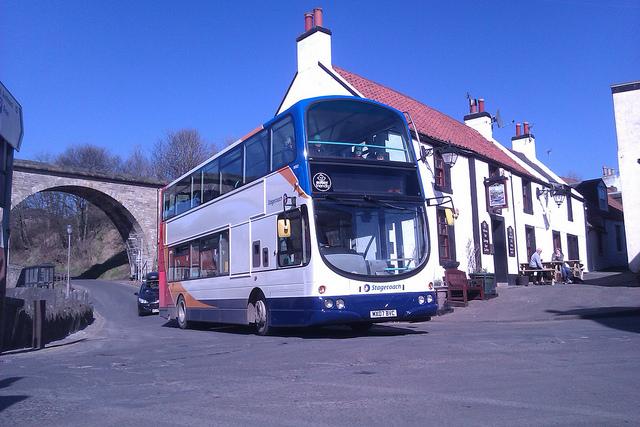Does the bus have big windows?
Be succinct. Yes. How many chimneys are on the roof?
Short answer required. 3. Is the bus a double decker?
Write a very short answer. Yes. 